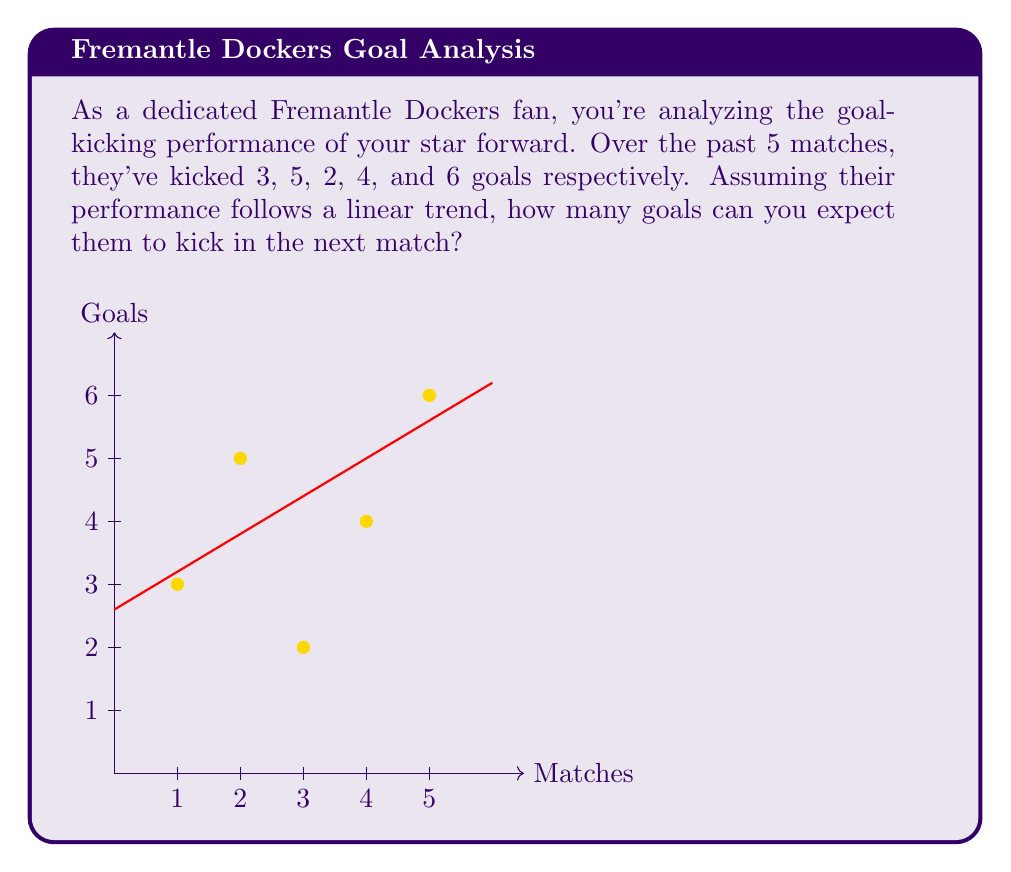Help me with this question. To predict the player's performance in the next match, we'll use linear regression:

1) First, let's set up our data:
   x (match number): 1, 2, 3, 4, 5
   y (goals): 3, 5, 2, 4, 6

2) We need to calculate the following:
   n = 5 (number of data points)
   Σx = 1 + 2 + 3 + 4 + 5 = 15
   Σy = 3 + 5 + 2 + 4 + 6 = 20
   Σ(x^2) = 1^2 + 2^2 + 3^2 + 4^2 + 5^2 = 55
   Σ(xy) = 1(3) + 2(5) + 3(2) + 4(4) + 5(6) = 70

3) Now we can use the linear regression formula:
   Slope (m) = $\frac{n\Sigma(xy) - \Sigma x \Sigma y}{n\Sigma(x^2) - (\Σx)^2}$
   
   $m = \frac{5(70) - (15)(20)}{5(55) - (15)^2} = \frac{350 - 300}{275 - 225} = \frac{50}{50} = 1$

4) To find the y-intercept (b):
   $b = \frac{\Sigma y - m\Sigma x}{n} = \frac{20 - 1(15)}{5} = 1$

5) Our linear equation is: y = mx + b = 1x + 1

6) To predict the goals for the next match (x = 6):
   y = 1(6) + 1 = 7

Therefore, based on the linear trend, we can expect the player to kick 7 goals in the next match.
Answer: 7 goals 